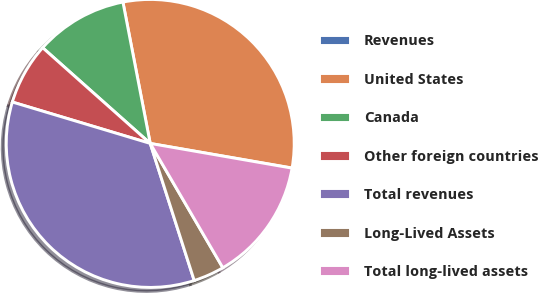Convert chart to OTSL. <chart><loc_0><loc_0><loc_500><loc_500><pie_chart><fcel>Revenues<fcel>United States<fcel>Canada<fcel>Other foreign countries<fcel>Total revenues<fcel>Long-Lived Assets<fcel>Total long-lived assets<nl><fcel>0.02%<fcel>30.76%<fcel>10.39%<fcel>6.93%<fcel>34.58%<fcel>3.47%<fcel>13.84%<nl></chart> 